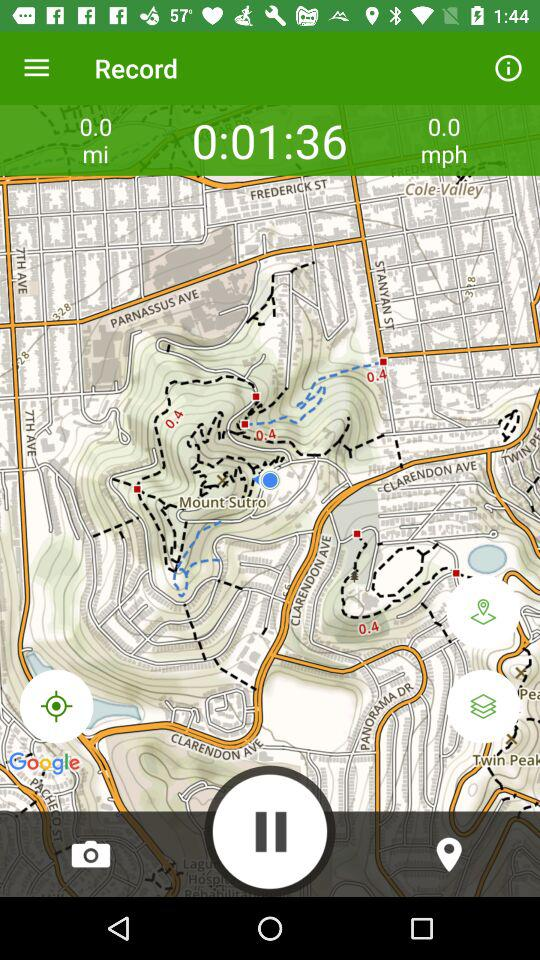How many trails are not found?
Answer the question using a single word or phrase. 0 